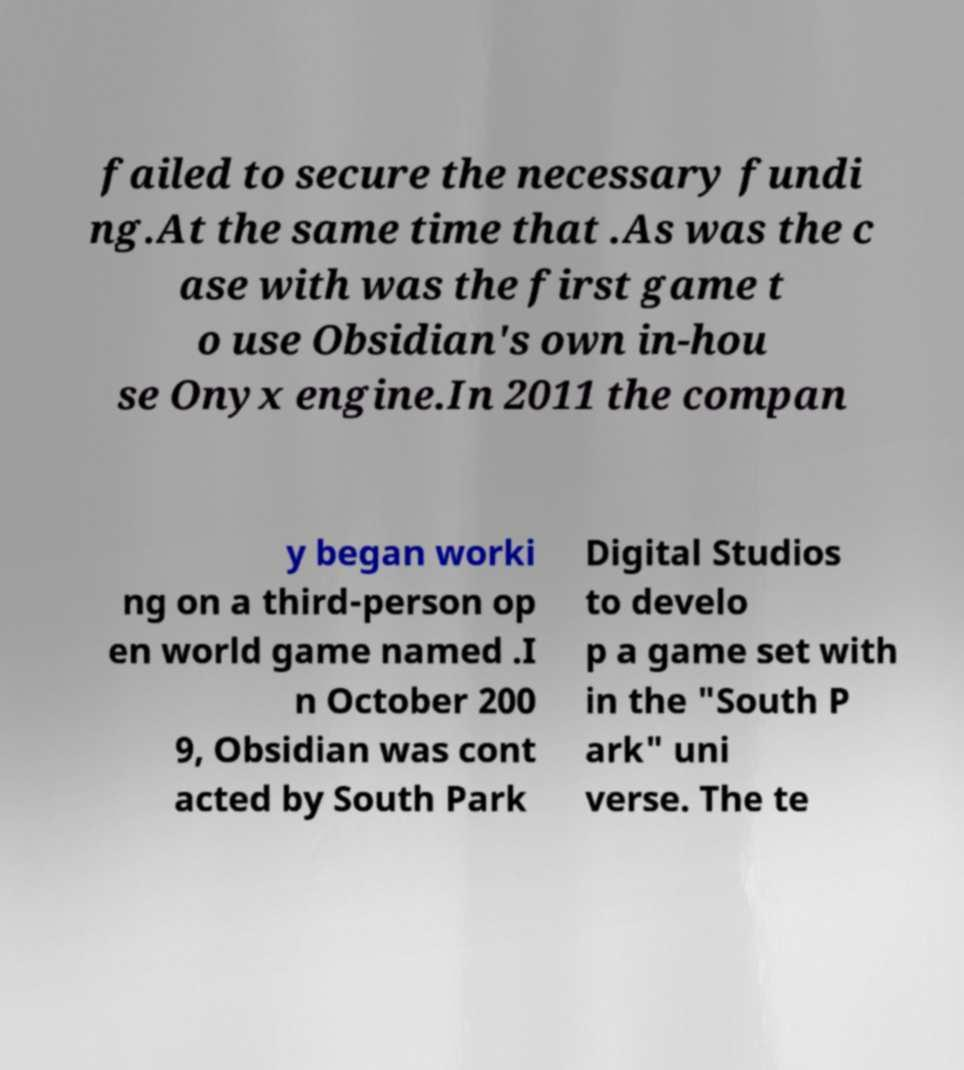There's text embedded in this image that I need extracted. Can you transcribe it verbatim? failed to secure the necessary fundi ng.At the same time that .As was the c ase with was the first game t o use Obsidian's own in-hou se Onyx engine.In 2011 the compan y began worki ng on a third-person op en world game named .I n October 200 9, Obsidian was cont acted by South Park Digital Studios to develo p a game set with in the "South P ark" uni verse. The te 